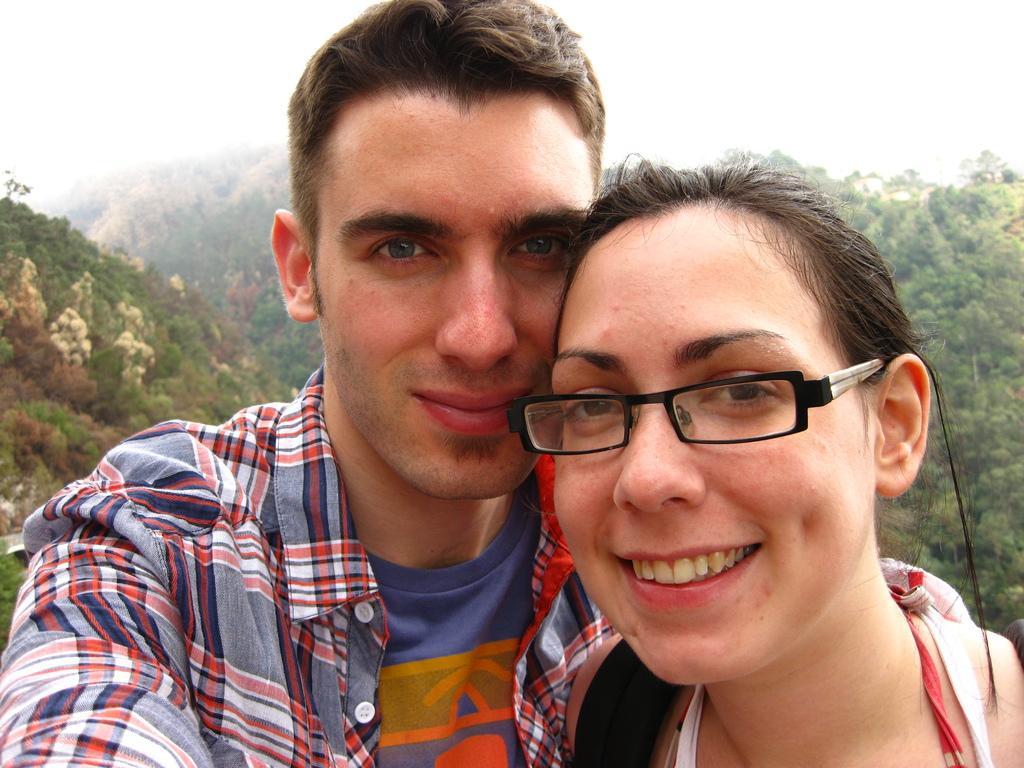How many people are in the image? There are two people in the image, a man and a woman. What are the man and woman doing in the image? The man and woman are standing together and smiling. What can be seen in the background of the image? There are mountains visible in the background of the image. What is the condition of the mountains in the image? The mountains are covered with trees. What type of bed can be seen in the image? There is no bed present in the image; it features a man and a woman standing together in front of mountains. What details can be observed about the man's clothing in the image? The provided facts do not mention any details about the man's clothing, so it cannot be determined from the image. 